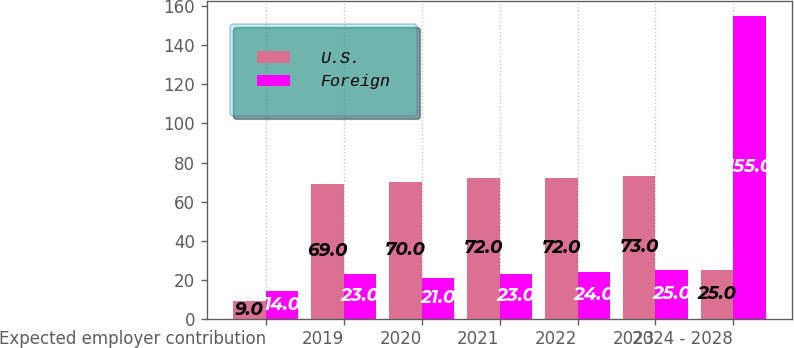Convert chart. <chart><loc_0><loc_0><loc_500><loc_500><stacked_bar_chart><ecel><fcel>Expected employer contribution<fcel>2019<fcel>2020<fcel>2021<fcel>2022<fcel>2023<fcel>2024 - 2028<nl><fcel>U.S.<fcel>9<fcel>69<fcel>70<fcel>72<fcel>72<fcel>73<fcel>25<nl><fcel>Foreign<fcel>14<fcel>23<fcel>21<fcel>23<fcel>24<fcel>25<fcel>155<nl></chart> 